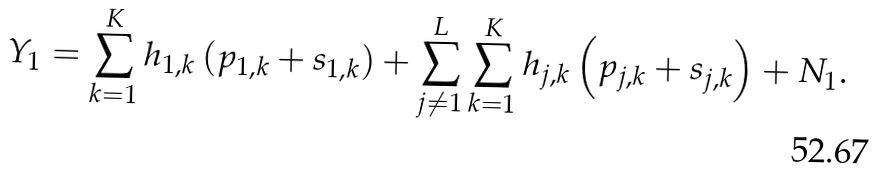Convert formula to latex. <formula><loc_0><loc_0><loc_500><loc_500>Y _ { 1 } = \sum _ { k = 1 } ^ { K } h _ { 1 , k } \left ( p _ { 1 , k } + s _ { 1 , k } \right ) + \sum _ { j \neq 1 } ^ { L } \sum _ { k = 1 } ^ { K } h _ { j , k } \left ( p _ { j , k } + s _ { j , k } \right ) + N _ { 1 } .</formula> 